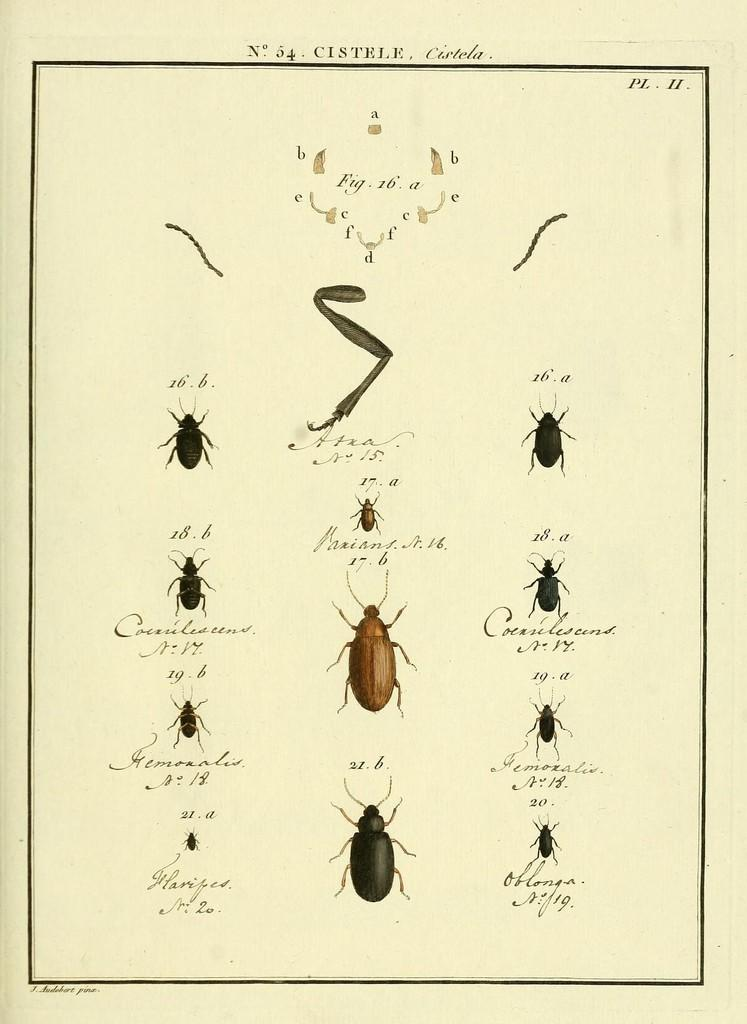What is the main subject of the wall chart in the image? The wall chart contains depictions of bugs. What else can be found on the wall chart besides the bug illustrations? There is text on the wall chart. What type of bird is perched on the stem of the plant in the image? There is no bird or plant present in the image; it only features a wall chart with bug illustrations and text. 